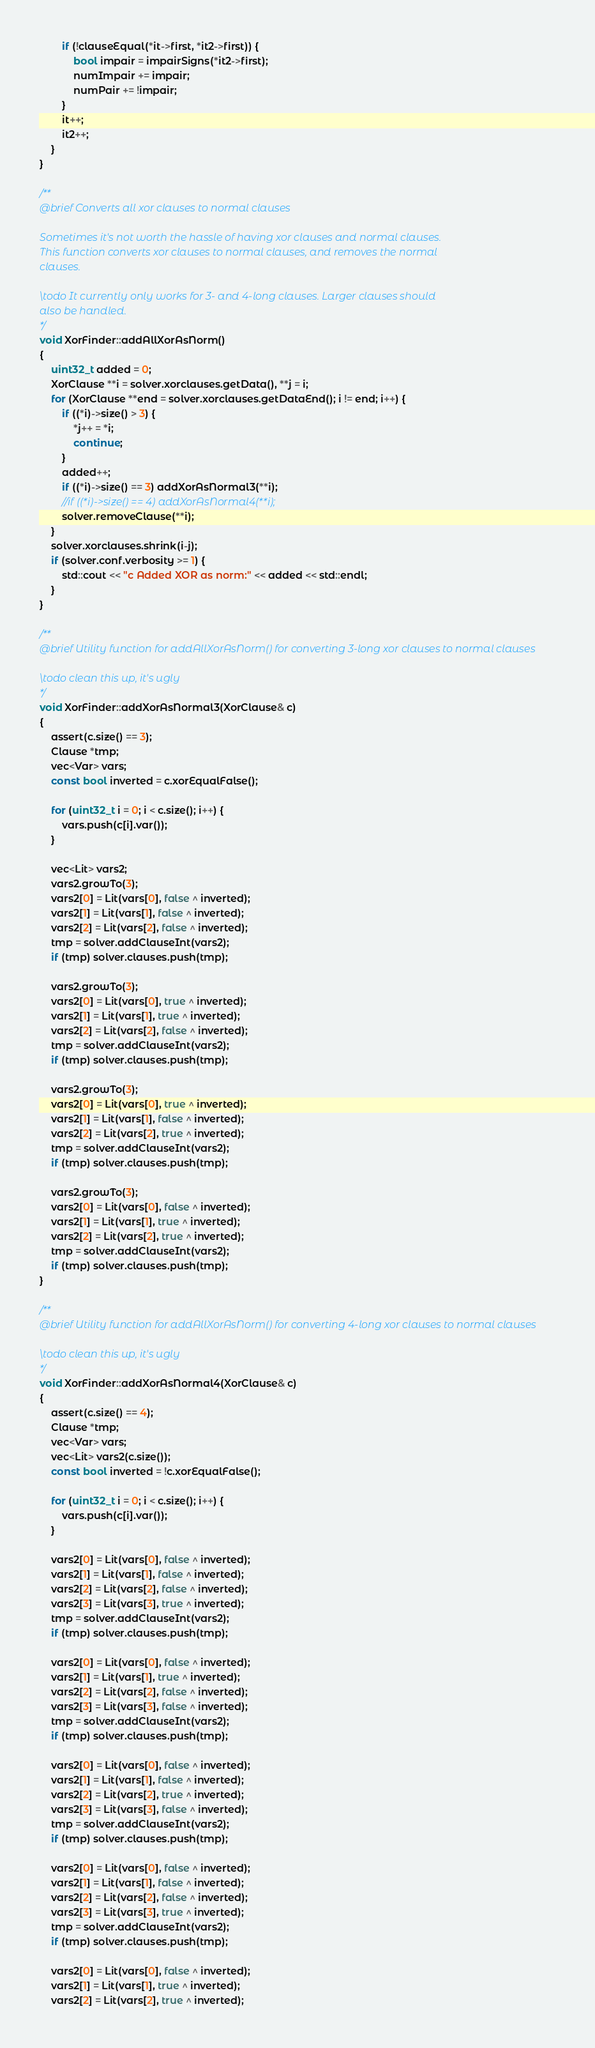<code> <loc_0><loc_0><loc_500><loc_500><_C++_>        if (!clauseEqual(*it->first, *it2->first)) {
            bool impair = impairSigns(*it2->first);
            numImpair += impair;
            numPair += !impair;
        }
        it++;
        it2++;
    }
}

/**
@brief Converts all xor clauses to normal clauses

Sometimes it's not worth the hassle of having xor clauses and normal clauses.
This function converts xor clauses to normal clauses, and removes the normal
clauses.

\todo It currently only works for 3- and 4-long clauses. Larger clauses should
also be handled.
*/
void XorFinder::addAllXorAsNorm()
{
    uint32_t added = 0;
    XorClause **i = solver.xorclauses.getData(), **j = i;
    for (XorClause **end = solver.xorclauses.getDataEnd(); i != end; i++) {
        if ((*i)->size() > 3) {
            *j++ = *i;
            continue;
        }
        added++;
        if ((*i)->size() == 3) addXorAsNormal3(**i);
        //if ((*i)->size() == 4) addXorAsNormal4(**i);
        solver.removeClause(**i);
    }
    solver.xorclauses.shrink(i-j);
    if (solver.conf.verbosity >= 1) {
        std::cout << "c Added XOR as norm:" << added << std::endl;
    }
}

/**
@brief Utility function for addAllXorAsNorm() for converting 3-long xor clauses to normal clauses

\todo clean this up, it's ugly
*/
void XorFinder::addXorAsNormal3(XorClause& c)
{
    assert(c.size() == 3);
    Clause *tmp;
    vec<Var> vars;
    const bool inverted = c.xorEqualFalse();

    for (uint32_t i = 0; i < c.size(); i++) {
        vars.push(c[i].var());
    }

    vec<Lit> vars2;
    vars2.growTo(3);
    vars2[0] = Lit(vars[0], false ^ inverted);
    vars2[1] = Lit(vars[1], false ^ inverted);
    vars2[2] = Lit(vars[2], false ^ inverted);
    tmp = solver.addClauseInt(vars2);
    if (tmp) solver.clauses.push(tmp);

    vars2.growTo(3);
    vars2[0] = Lit(vars[0], true ^ inverted);
    vars2[1] = Lit(vars[1], true ^ inverted);
    vars2[2] = Lit(vars[2], false ^ inverted);
    tmp = solver.addClauseInt(vars2);
    if (tmp) solver.clauses.push(tmp);

    vars2.growTo(3);
    vars2[0] = Lit(vars[0], true ^ inverted);
    vars2[1] = Lit(vars[1], false ^ inverted);
    vars2[2] = Lit(vars[2], true ^ inverted);
    tmp = solver.addClauseInt(vars2);
    if (tmp) solver.clauses.push(tmp);

    vars2.growTo(3);
    vars2[0] = Lit(vars[0], false ^ inverted);
    vars2[1] = Lit(vars[1], true ^ inverted);
    vars2[2] = Lit(vars[2], true ^ inverted);
    tmp = solver.addClauseInt(vars2);
    if (tmp) solver.clauses.push(tmp);
}

/**
@brief Utility function for addAllXorAsNorm() for converting 4-long xor clauses to normal clauses

\todo clean this up, it's ugly
*/
void XorFinder::addXorAsNormal4(XorClause& c)
{
    assert(c.size() == 4);
    Clause *tmp;
    vec<Var> vars;
    vec<Lit> vars2(c.size());
    const bool inverted = !c.xorEqualFalse();

    for (uint32_t i = 0; i < c.size(); i++) {
        vars.push(c[i].var());
    }

    vars2[0] = Lit(vars[0], false ^ inverted);
    vars2[1] = Lit(vars[1], false ^ inverted);
    vars2[2] = Lit(vars[2], false ^ inverted);
    vars2[3] = Lit(vars[3], true ^ inverted);
    tmp = solver.addClauseInt(vars2);
    if (tmp) solver.clauses.push(tmp);

    vars2[0] = Lit(vars[0], false ^ inverted);
    vars2[1] = Lit(vars[1], true ^ inverted);
    vars2[2] = Lit(vars[2], false ^ inverted);
    vars2[3] = Lit(vars[3], false ^ inverted);
    tmp = solver.addClauseInt(vars2);
    if (tmp) solver.clauses.push(tmp);

    vars2[0] = Lit(vars[0], false ^ inverted);
    vars2[1] = Lit(vars[1], false ^ inverted);
    vars2[2] = Lit(vars[2], true ^ inverted);
    vars2[3] = Lit(vars[3], false ^ inverted);
    tmp = solver.addClauseInt(vars2);
    if (tmp) solver.clauses.push(tmp);

    vars2[0] = Lit(vars[0], false ^ inverted);
    vars2[1] = Lit(vars[1], false ^ inverted);
    vars2[2] = Lit(vars[2], false ^ inverted);
    vars2[3] = Lit(vars[3], true ^ inverted);
    tmp = solver.addClauseInt(vars2);
    if (tmp) solver.clauses.push(tmp);

    vars2[0] = Lit(vars[0], false ^ inverted);
    vars2[1] = Lit(vars[1], true ^ inverted);
    vars2[2] = Lit(vars[2], true ^ inverted);</code> 